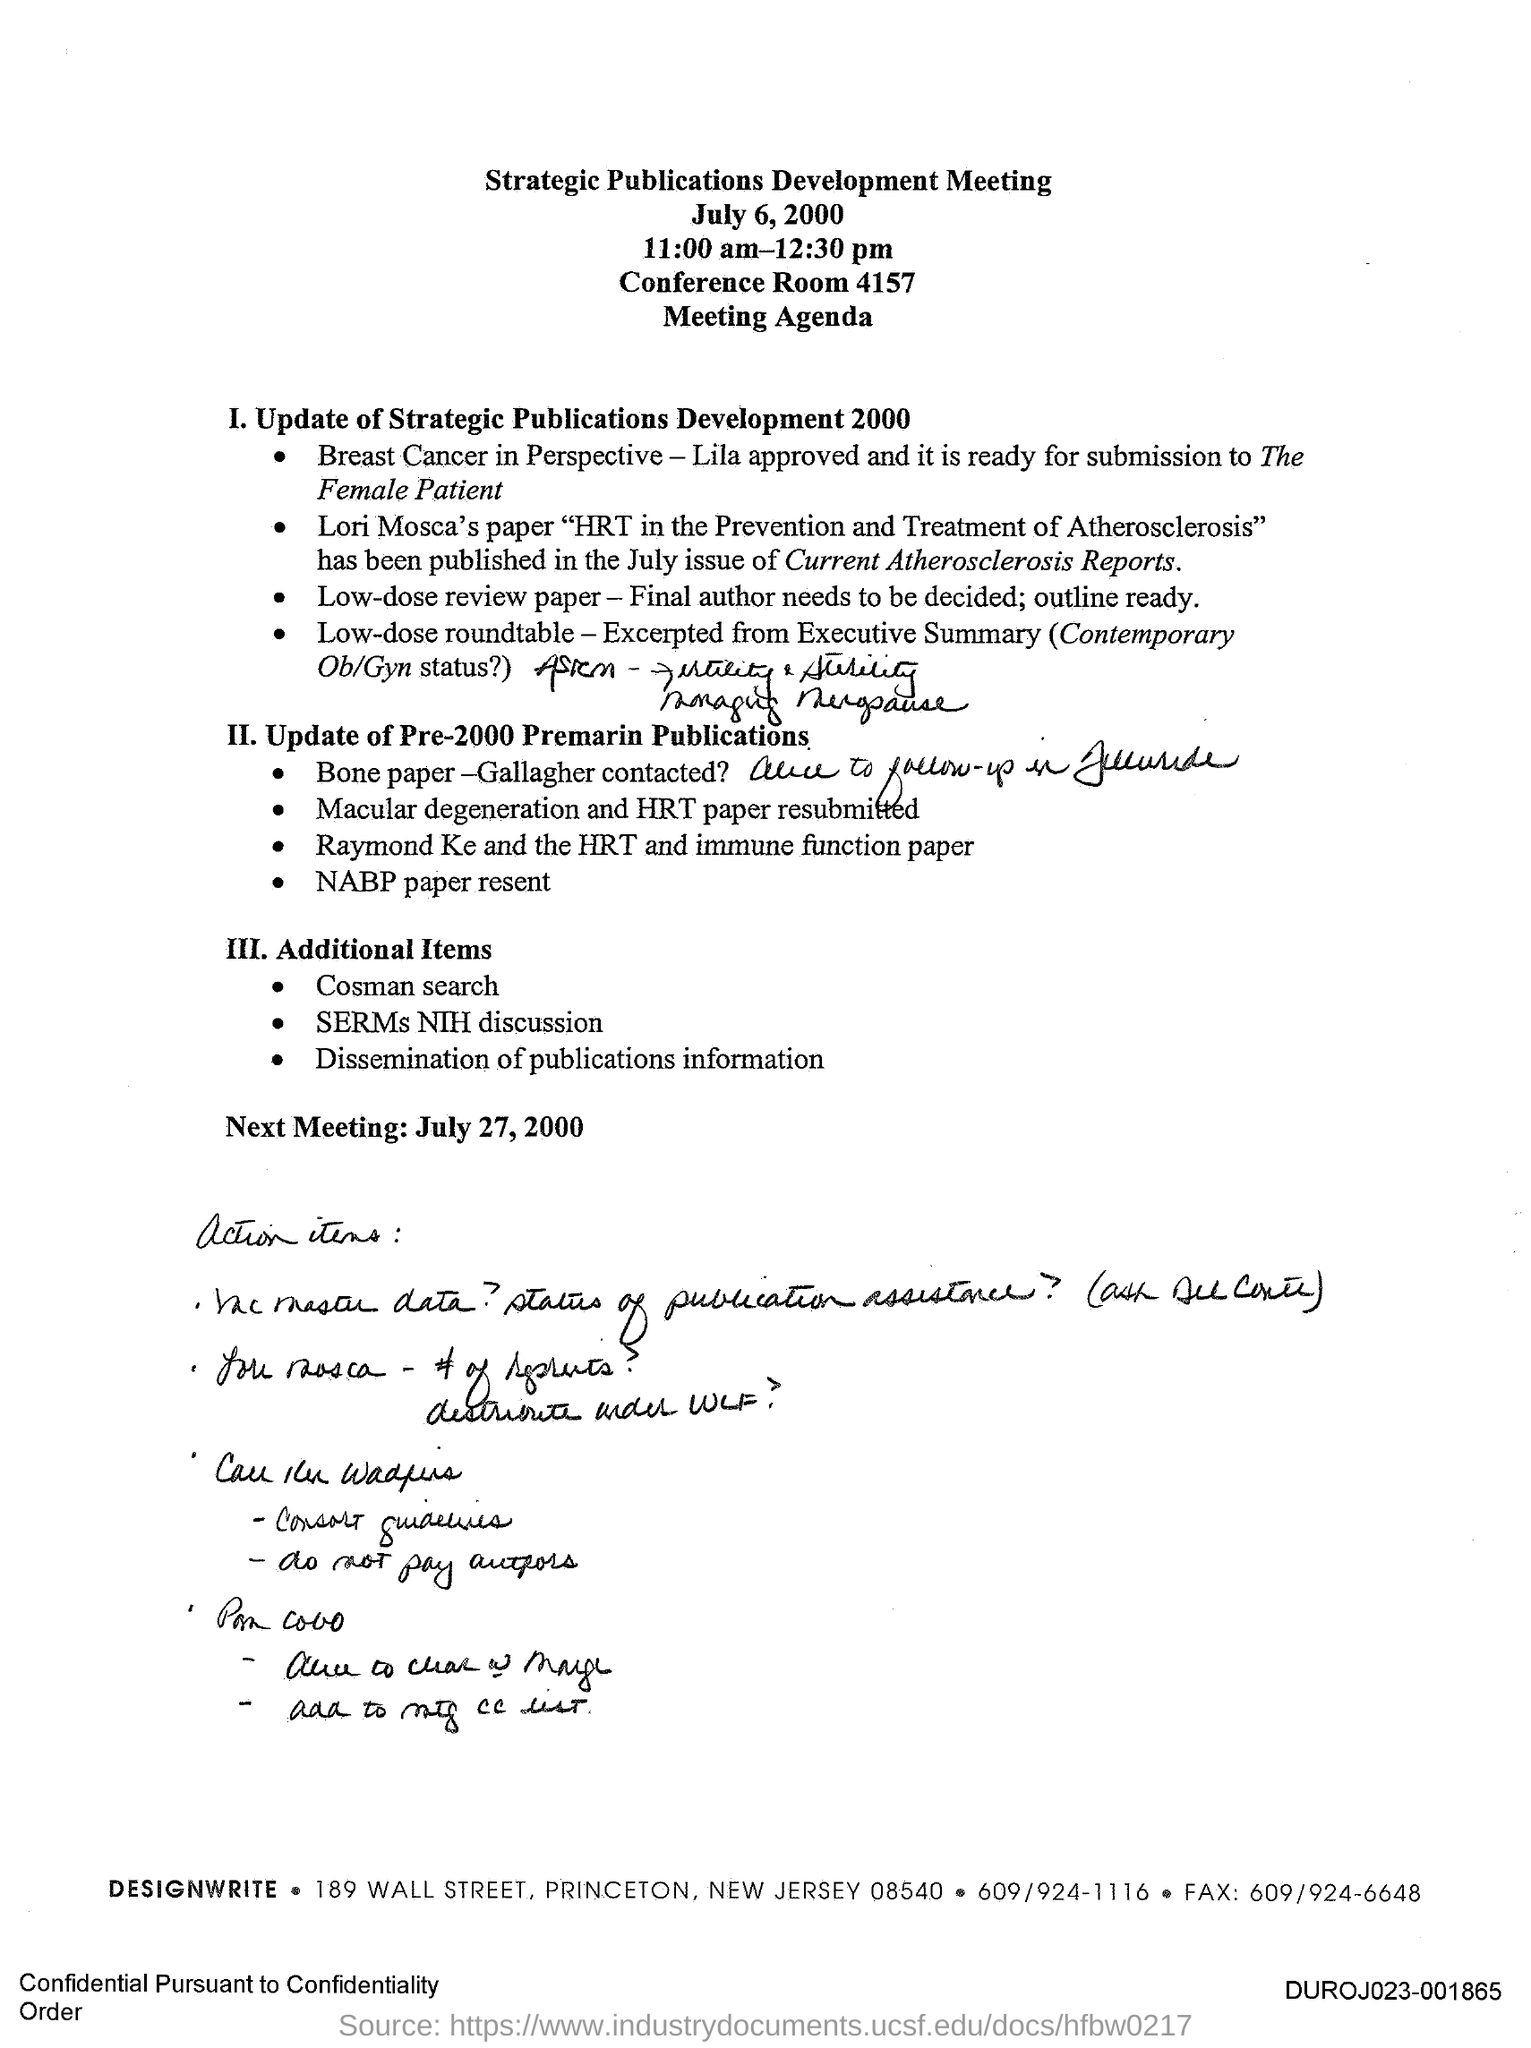When is the Strategic Publications Development Meeting held?
Your answer should be compact. July 6, 2000. Where is the Strategic Publications Development Meeting held?
Keep it short and to the point. Conference Room 4157. When is the Next Meeting?
Your answer should be compact. July 27, 2000. 